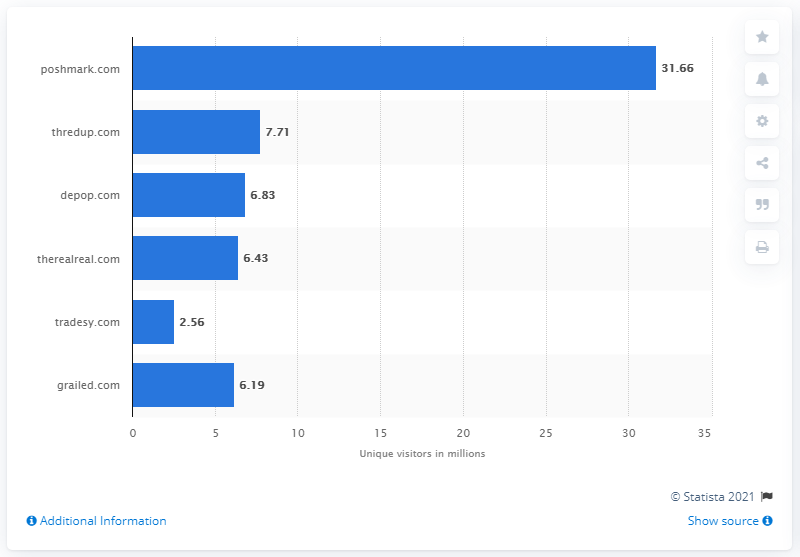Give some essential details in this illustration. In the month of December, Poshmark.com had approximately 31,667 monthly visitors. 